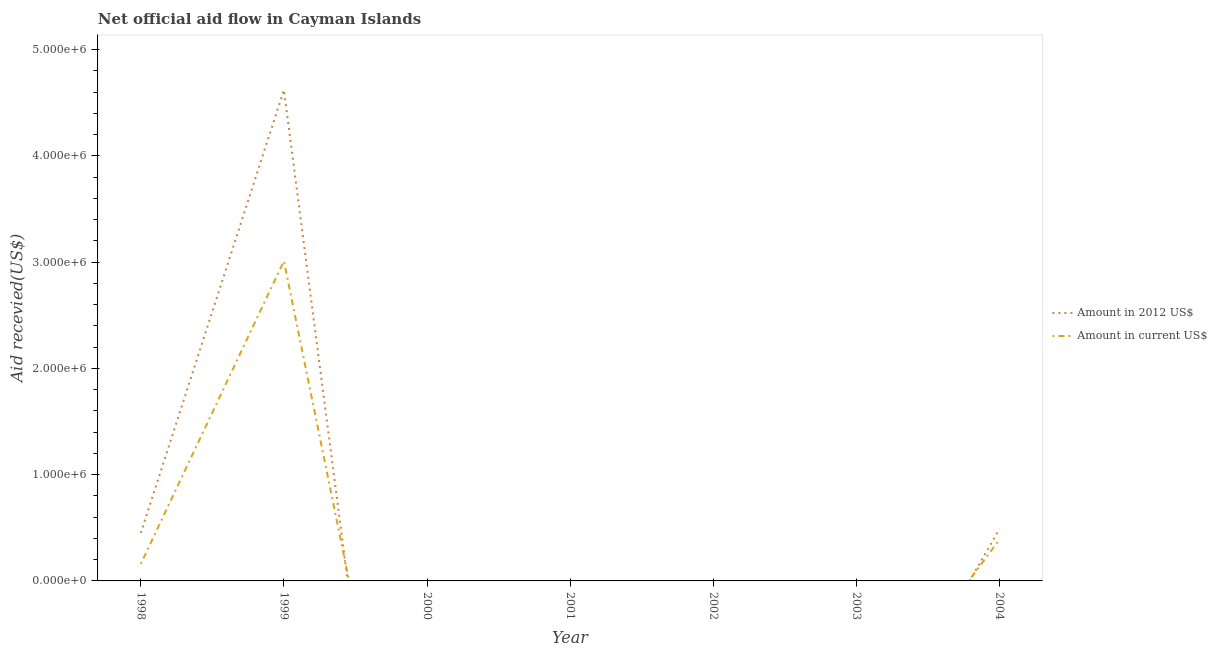How many different coloured lines are there?
Ensure brevity in your answer.  2. Does the line corresponding to amount of aid received(expressed in 2012 us$) intersect with the line corresponding to amount of aid received(expressed in us$)?
Ensure brevity in your answer.  Yes. Is the number of lines equal to the number of legend labels?
Give a very brief answer. No. Across all years, what is the maximum amount of aid received(expressed in us$)?
Your answer should be compact. 3.01e+06. Across all years, what is the minimum amount of aid received(expressed in 2012 us$)?
Give a very brief answer. 0. What is the total amount of aid received(expressed in us$) in the graph?
Ensure brevity in your answer.  3.56e+06. What is the difference between the amount of aid received(expressed in us$) in 1999 and that in 2004?
Keep it short and to the point. 2.62e+06. What is the average amount of aid received(expressed in 2012 us$) per year?
Ensure brevity in your answer.  7.94e+05. In the year 1999, what is the difference between the amount of aid received(expressed in 2012 us$) and amount of aid received(expressed in us$)?
Give a very brief answer. 1.61e+06. In how many years, is the amount of aid received(expressed in 2012 us$) greater than 3400000 US$?
Give a very brief answer. 1. What is the ratio of the amount of aid received(expressed in 2012 us$) in 1998 to that in 2004?
Ensure brevity in your answer.  0.92. Is the difference between the amount of aid received(expressed in us$) in 1998 and 1999 greater than the difference between the amount of aid received(expressed in 2012 us$) in 1998 and 1999?
Provide a short and direct response. Yes. What is the difference between the highest and the second highest amount of aid received(expressed in us$)?
Your response must be concise. 2.62e+06. What is the difference between the highest and the lowest amount of aid received(expressed in 2012 us$)?
Your response must be concise. 4.62e+06. In how many years, is the amount of aid received(expressed in us$) greater than the average amount of aid received(expressed in us$) taken over all years?
Ensure brevity in your answer.  1. Does the amount of aid received(expressed in us$) monotonically increase over the years?
Your response must be concise. No. Is the amount of aid received(expressed in us$) strictly less than the amount of aid received(expressed in 2012 us$) over the years?
Offer a very short reply. No. Are the values on the major ticks of Y-axis written in scientific E-notation?
Your answer should be compact. Yes. Does the graph contain any zero values?
Your answer should be compact. Yes. Where does the legend appear in the graph?
Provide a succinct answer. Center right. How many legend labels are there?
Your answer should be compact. 2. How are the legend labels stacked?
Your answer should be very brief. Vertical. What is the title of the graph?
Provide a succinct answer. Net official aid flow in Cayman Islands. Does "Male entrants" appear as one of the legend labels in the graph?
Make the answer very short. No. What is the label or title of the Y-axis?
Your response must be concise. Aid recevied(US$). What is the Aid recevied(US$) in Amount in 2012 US$ in 1998?
Your answer should be very brief. 4.50e+05. What is the Aid recevied(US$) in Amount in 2012 US$ in 1999?
Your answer should be very brief. 4.62e+06. What is the Aid recevied(US$) of Amount in current US$ in 1999?
Ensure brevity in your answer.  3.01e+06. What is the Aid recevied(US$) in Amount in 2012 US$ in 2000?
Make the answer very short. 0. What is the Aid recevied(US$) of Amount in current US$ in 2000?
Ensure brevity in your answer.  0. What is the Aid recevied(US$) in Amount in current US$ in 2001?
Offer a terse response. 0. What is the Aid recevied(US$) in Amount in 2012 US$ in 2002?
Your answer should be compact. 0. What is the Aid recevied(US$) in Amount in current US$ in 2002?
Your answer should be compact. 0. What is the Aid recevied(US$) of Amount in current US$ in 2004?
Provide a succinct answer. 3.90e+05. Across all years, what is the maximum Aid recevied(US$) in Amount in 2012 US$?
Your response must be concise. 4.62e+06. Across all years, what is the maximum Aid recevied(US$) of Amount in current US$?
Offer a terse response. 3.01e+06. Across all years, what is the minimum Aid recevied(US$) of Amount in current US$?
Your answer should be compact. 0. What is the total Aid recevied(US$) in Amount in 2012 US$ in the graph?
Offer a terse response. 5.56e+06. What is the total Aid recevied(US$) of Amount in current US$ in the graph?
Your answer should be compact. 3.56e+06. What is the difference between the Aid recevied(US$) in Amount in 2012 US$ in 1998 and that in 1999?
Give a very brief answer. -4.17e+06. What is the difference between the Aid recevied(US$) of Amount in current US$ in 1998 and that in 1999?
Offer a very short reply. -2.85e+06. What is the difference between the Aid recevied(US$) of Amount in 2012 US$ in 1999 and that in 2004?
Your answer should be compact. 4.13e+06. What is the difference between the Aid recevied(US$) of Amount in current US$ in 1999 and that in 2004?
Ensure brevity in your answer.  2.62e+06. What is the difference between the Aid recevied(US$) in Amount in 2012 US$ in 1998 and the Aid recevied(US$) in Amount in current US$ in 1999?
Your answer should be compact. -2.56e+06. What is the difference between the Aid recevied(US$) of Amount in 2012 US$ in 1999 and the Aid recevied(US$) of Amount in current US$ in 2004?
Ensure brevity in your answer.  4.23e+06. What is the average Aid recevied(US$) in Amount in 2012 US$ per year?
Offer a very short reply. 7.94e+05. What is the average Aid recevied(US$) in Amount in current US$ per year?
Your answer should be very brief. 5.09e+05. In the year 1998, what is the difference between the Aid recevied(US$) of Amount in 2012 US$ and Aid recevied(US$) of Amount in current US$?
Provide a succinct answer. 2.90e+05. In the year 1999, what is the difference between the Aid recevied(US$) in Amount in 2012 US$ and Aid recevied(US$) in Amount in current US$?
Ensure brevity in your answer.  1.61e+06. What is the ratio of the Aid recevied(US$) of Amount in 2012 US$ in 1998 to that in 1999?
Your answer should be compact. 0.1. What is the ratio of the Aid recevied(US$) in Amount in current US$ in 1998 to that in 1999?
Keep it short and to the point. 0.05. What is the ratio of the Aid recevied(US$) of Amount in 2012 US$ in 1998 to that in 2004?
Provide a succinct answer. 0.92. What is the ratio of the Aid recevied(US$) of Amount in current US$ in 1998 to that in 2004?
Offer a very short reply. 0.41. What is the ratio of the Aid recevied(US$) of Amount in 2012 US$ in 1999 to that in 2004?
Give a very brief answer. 9.43. What is the ratio of the Aid recevied(US$) of Amount in current US$ in 1999 to that in 2004?
Provide a succinct answer. 7.72. What is the difference between the highest and the second highest Aid recevied(US$) in Amount in 2012 US$?
Your answer should be compact. 4.13e+06. What is the difference between the highest and the second highest Aid recevied(US$) of Amount in current US$?
Ensure brevity in your answer.  2.62e+06. What is the difference between the highest and the lowest Aid recevied(US$) of Amount in 2012 US$?
Provide a short and direct response. 4.62e+06. What is the difference between the highest and the lowest Aid recevied(US$) in Amount in current US$?
Ensure brevity in your answer.  3.01e+06. 